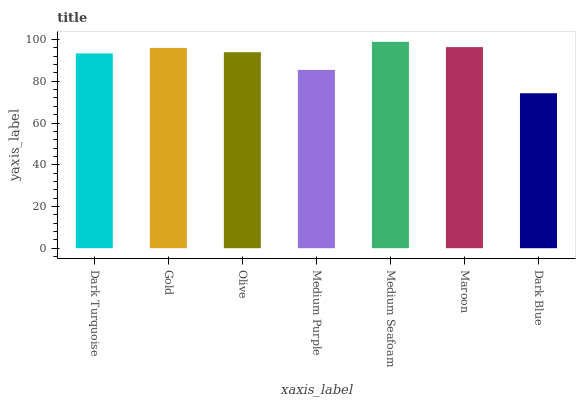Is Dark Blue the minimum?
Answer yes or no. Yes. Is Medium Seafoam the maximum?
Answer yes or no. Yes. Is Gold the minimum?
Answer yes or no. No. Is Gold the maximum?
Answer yes or no. No. Is Gold greater than Dark Turquoise?
Answer yes or no. Yes. Is Dark Turquoise less than Gold?
Answer yes or no. Yes. Is Dark Turquoise greater than Gold?
Answer yes or no. No. Is Gold less than Dark Turquoise?
Answer yes or no. No. Is Olive the high median?
Answer yes or no. Yes. Is Olive the low median?
Answer yes or no. Yes. Is Medium Seafoam the high median?
Answer yes or no. No. Is Dark Blue the low median?
Answer yes or no. No. 